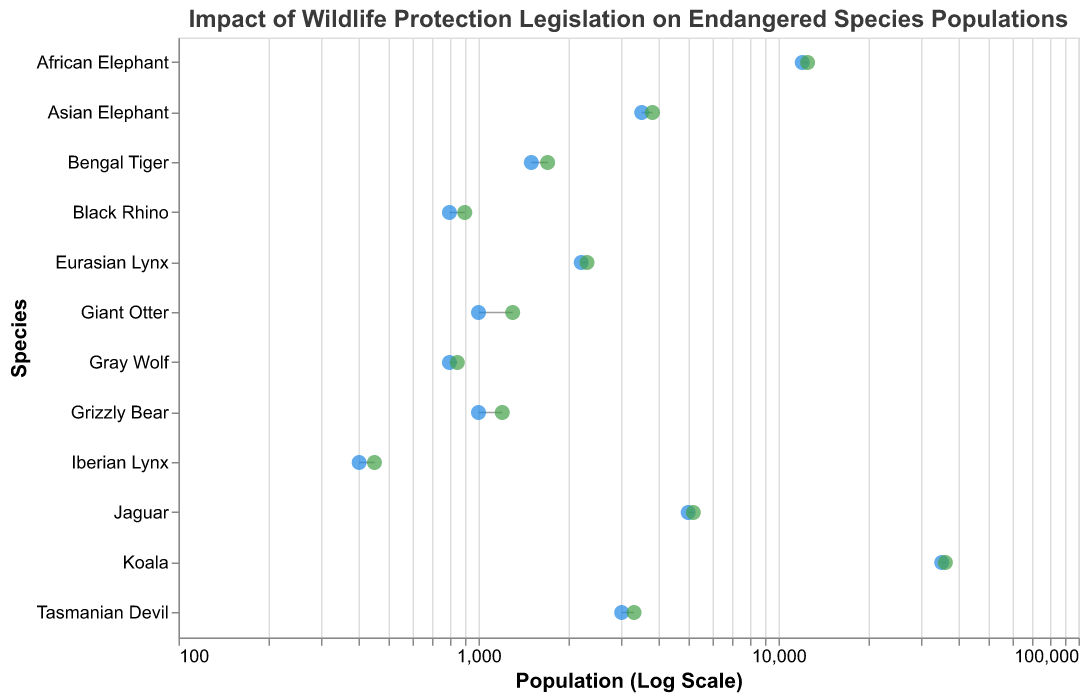How many regions are represented in the figure? The plot lists various species along the y-axis, each uniquely associated with a region. By counting these unique region names, we determine there are five distinct regions represented: North America, South America, Africa, Asia, Europe, and Oceania.
Answer: 6 Which region has the most significant increase in the population of any species after legislation? Look for the largest difference between the pre-legislation and post-legislation points (horizontal distance) on the plot. This increase appears to be for the Giant Otter in South America.
Answer: South America Which species in Asia showed a higher increase in population, the Bengal Tiger or the Asian Elephant? By comparing the horizontal lengths of the dumbbell lines for Bengal Tiger and Asian Elephant, it is clear that the Bengal Tiger showed an increase of 200 (1700-1500) whereas the Asian Elephant increased by 300 (3800-3500).
Answer: Asian Elephant How much did the population of the Iberian Lynx in Europe increase after legislation? Check the start and end points of the dumbbell line for the Iberian Lynx in Europe. The pre-legislation population was 400, and the post-legislation population was 450, giving an increase of 450 - 400 = 50.
Answer: 50 What is the ratio of the post-legislation population to the pre-legislation population for the North American Grizzly Bear? The pre-legislation population is 1000, and the post-legislation population is 1200. Thus, the ratio is 1200 / 1000, which simplifies to 1.2.
Answer: 1.2 Which species had the least change in population numbers post-legislation? Identify the species with the shortest dumbbell line, indicating the smallest difference between pre-legislation and post-legislation populations. The Gray Wolf in North America shows the smallest increase (50).
Answer: Gray Wolf Which region has the most diverse impact on species post-legislation, in terms of variety in population changes? Assess the spread of the dumbbell lines for all species within each region. Regions with a wide range of increases indicate more diverse impacts. North America shows both minimal (50) and moderate (200) changes in population numbers.
Answer: North America Which species had the highest pre-legislation population in Oceania? Compare the pre-legislation populations of the species in Oceania. The Koala had a pre-legislation population of 35000, which is higher than the Tasmanian Devil's 3000.
Answer: Koala Overall, did the wildlife protection legislation have a positive impact on all listed species? By examining the shifts in population for each species, we see that each species' post-legislation population is higher than their pre-legislation population, indicating a positive impact.
Answer: Yes 